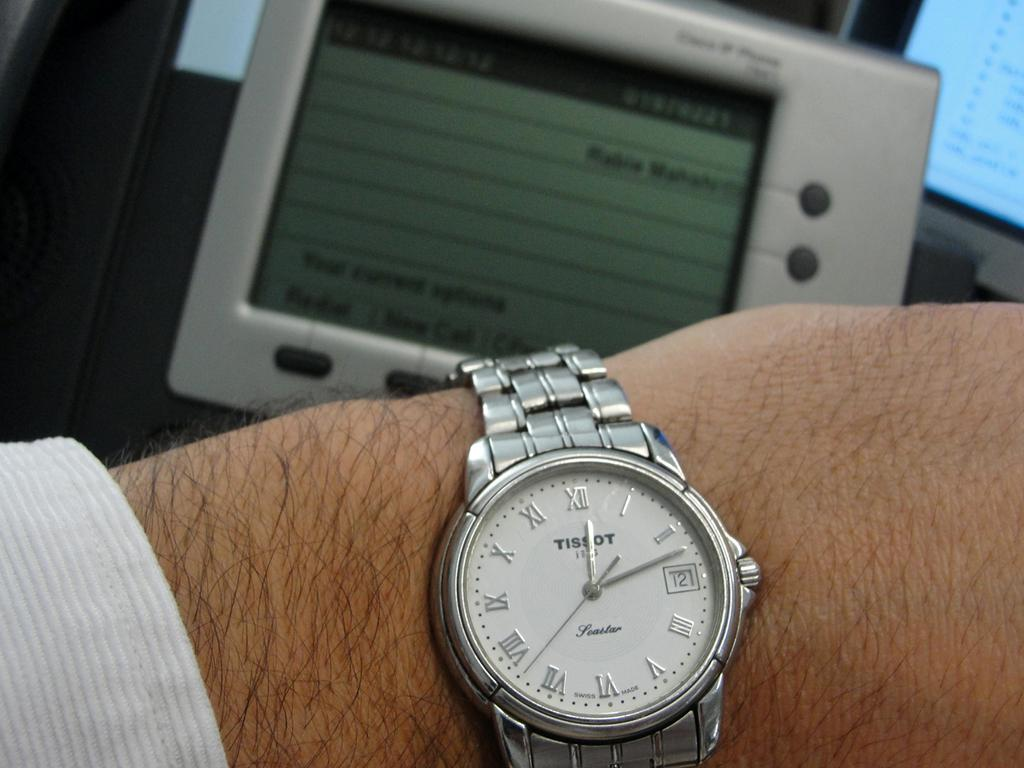<image>
Summarize the visual content of the image. A man's wristwatch states that it is the twelfth day of the month. 